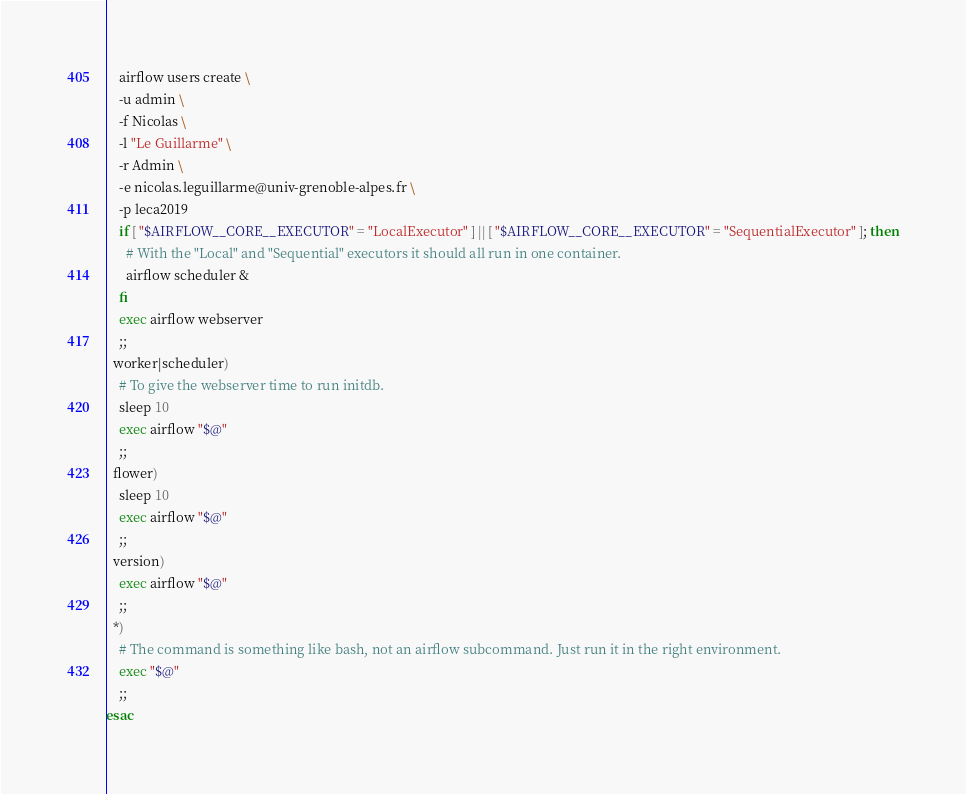Convert code to text. <code><loc_0><loc_0><loc_500><loc_500><_Bash_>    airflow users create \
    -u admin \
    -f Nicolas \
    -l "Le Guillarme" \
    -r Admin \
    -e nicolas.leguillarme@univ-grenoble-alpes.fr \
    -p leca2019
    if [ "$AIRFLOW__CORE__EXECUTOR" = "LocalExecutor" ] || [ "$AIRFLOW__CORE__EXECUTOR" = "SequentialExecutor" ]; then
      # With the "Local" and "Sequential" executors it should all run in one container.
      airflow scheduler &
    fi
    exec airflow webserver
    ;;
  worker|scheduler)
    # To give the webserver time to run initdb.
    sleep 10
    exec airflow "$@"
    ;;
  flower)
    sleep 10
    exec airflow "$@"
    ;;
  version)
    exec airflow "$@"
    ;;
  *)
    # The command is something like bash, not an airflow subcommand. Just run it in the right environment.
    exec "$@"
    ;;
esac
</code> 